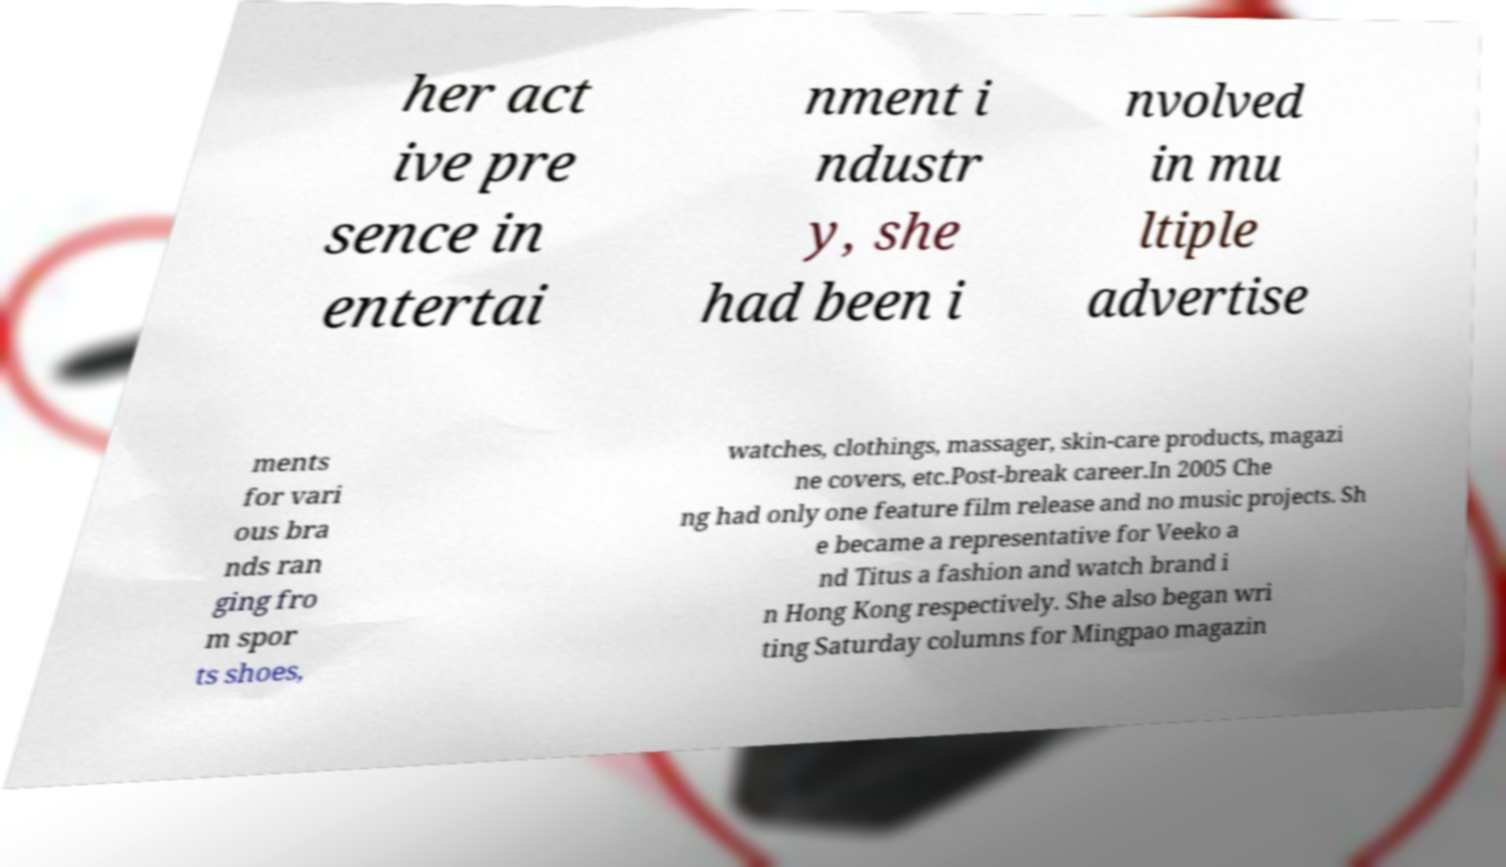Please identify and transcribe the text found in this image. her act ive pre sence in entertai nment i ndustr y, she had been i nvolved in mu ltiple advertise ments for vari ous bra nds ran ging fro m spor ts shoes, watches, clothings, massager, skin-care products, magazi ne covers, etc.Post-break career.In 2005 Che ng had only one feature film release and no music projects. Sh e became a representative for Veeko a nd Titus a fashion and watch brand i n Hong Kong respectively. She also began wri ting Saturday columns for Mingpao magazin 